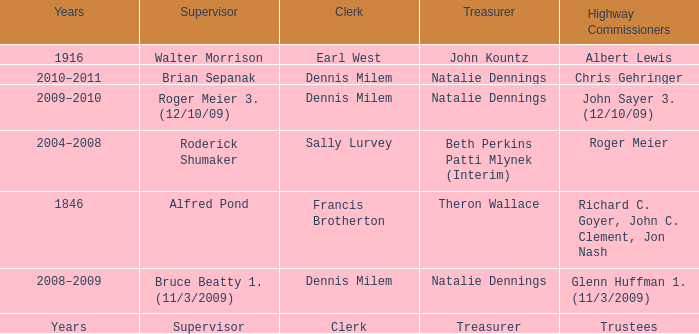Who was the clerk when the highway commissioner was Albert Lewis? Earl West. 